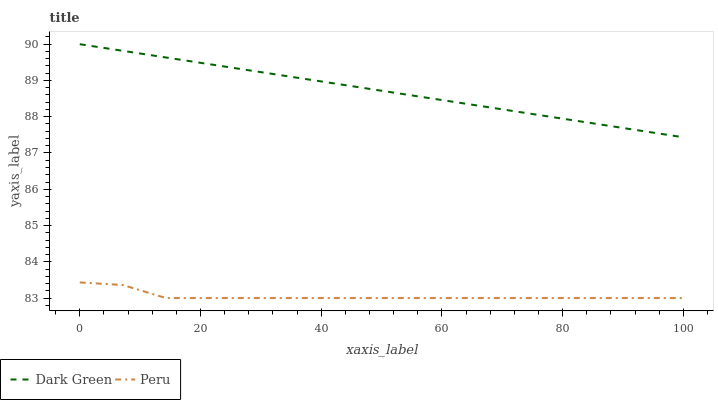Does Peru have the minimum area under the curve?
Answer yes or no. Yes. Does Dark Green have the maximum area under the curve?
Answer yes or no. Yes. Does Dark Green have the minimum area under the curve?
Answer yes or no. No. Is Dark Green the smoothest?
Answer yes or no. Yes. Is Peru the roughest?
Answer yes or no. Yes. Is Dark Green the roughest?
Answer yes or no. No. Does Peru have the lowest value?
Answer yes or no. Yes. Does Dark Green have the lowest value?
Answer yes or no. No. Does Dark Green have the highest value?
Answer yes or no. Yes. Is Peru less than Dark Green?
Answer yes or no. Yes. Is Dark Green greater than Peru?
Answer yes or no. Yes. Does Peru intersect Dark Green?
Answer yes or no. No. 